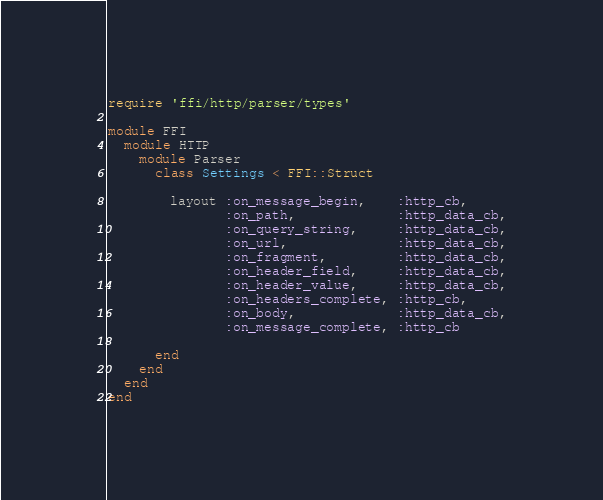Convert code to text. <code><loc_0><loc_0><loc_500><loc_500><_Ruby_>require 'ffi/http/parser/types'

module FFI
  module HTTP
    module Parser
      class Settings < FFI::Struct

        layout :on_message_begin,    :http_cb,
               :on_path,             :http_data_cb,
               :on_query_string,     :http_data_cb,
               :on_url,              :http_data_cb,
               :on_fragment,         :http_data_cb,
               :on_header_field,     :http_data_cb,
               :on_header_value,     :http_data_cb,
               :on_headers_complete, :http_cb,
               :on_body,             :http_data_cb,
               :on_message_complete, :http_cb

      end
    end
  end
end
</code> 